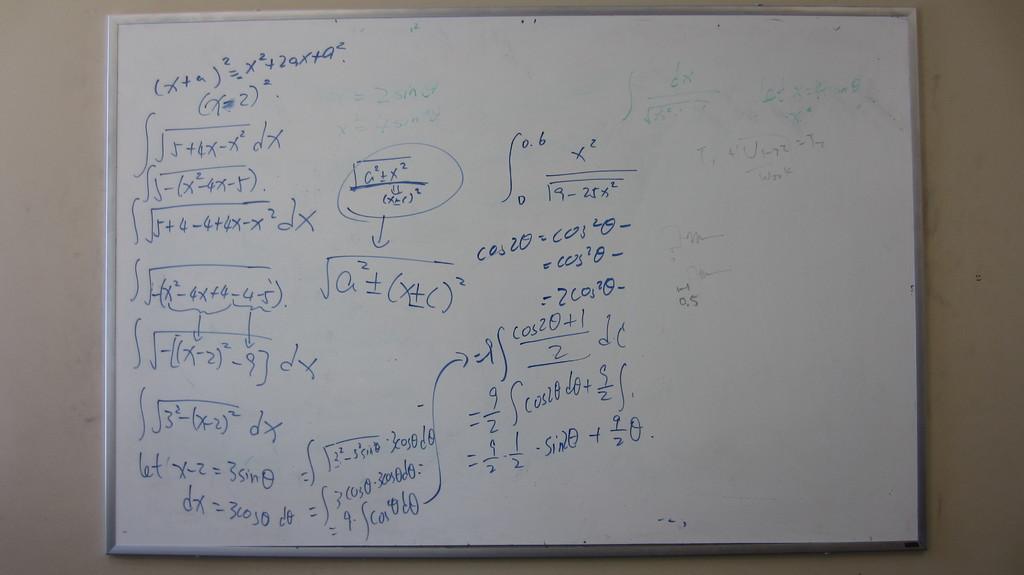Are those math formulas?
Your response must be concise. Yes. 